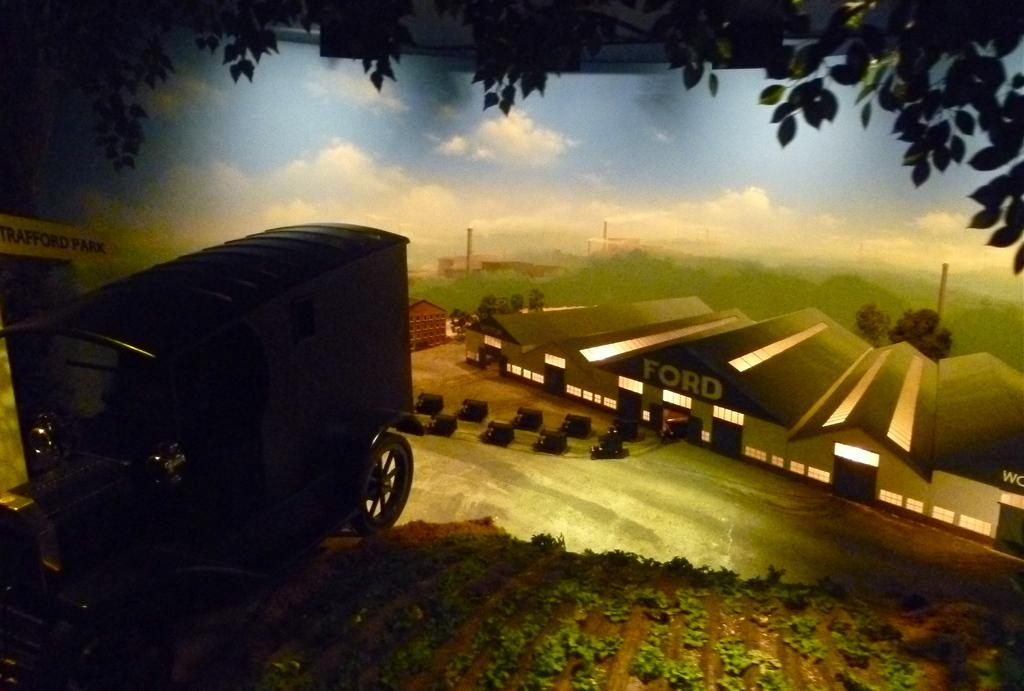What is located on the left side of the image? There is a cart on the left side of the image. What type of vegetation can be seen in the image? There are many leaves in the image. What is visible in the background of the image? The background of the image is the blue sky. Where is the fold in the image? There is no fold present in the image. What type of spot can be seen on the cart in the image? There are no spots visible on the cart in the image. 